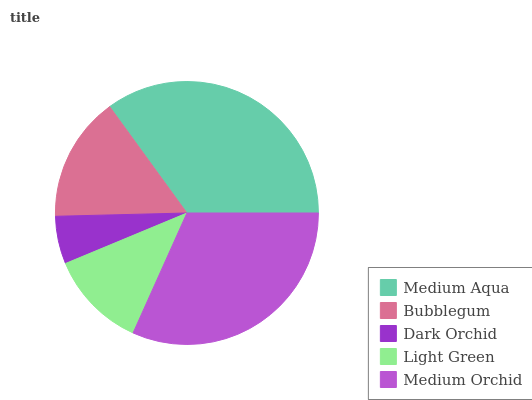Is Dark Orchid the minimum?
Answer yes or no. Yes. Is Medium Aqua the maximum?
Answer yes or no. Yes. Is Bubblegum the minimum?
Answer yes or no. No. Is Bubblegum the maximum?
Answer yes or no. No. Is Medium Aqua greater than Bubblegum?
Answer yes or no. Yes. Is Bubblegum less than Medium Aqua?
Answer yes or no. Yes. Is Bubblegum greater than Medium Aqua?
Answer yes or no. No. Is Medium Aqua less than Bubblegum?
Answer yes or no. No. Is Bubblegum the high median?
Answer yes or no. Yes. Is Bubblegum the low median?
Answer yes or no. Yes. Is Light Green the high median?
Answer yes or no. No. Is Dark Orchid the low median?
Answer yes or no. No. 